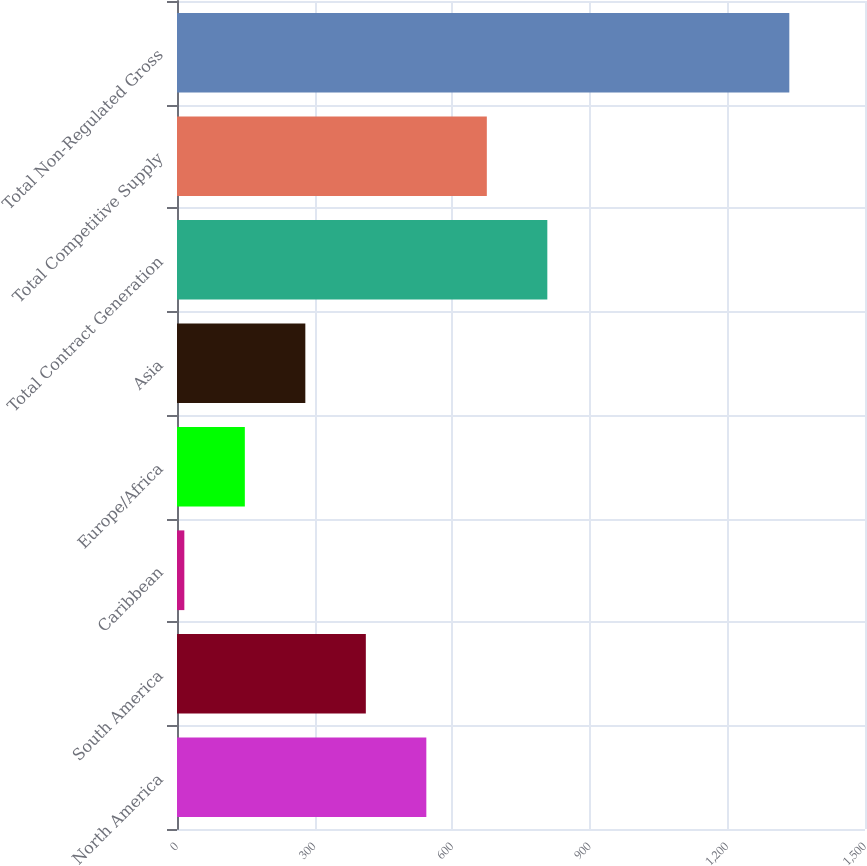Convert chart. <chart><loc_0><loc_0><loc_500><loc_500><bar_chart><fcel>North America<fcel>South America<fcel>Caribbean<fcel>Europe/Africa<fcel>Asia<fcel>Total Contract Generation<fcel>Total Competitive Supply<fcel>Total Non-Regulated Gross<nl><fcel>543.6<fcel>411.7<fcel>16<fcel>147.9<fcel>279.8<fcel>807.4<fcel>675.5<fcel>1335<nl></chart> 